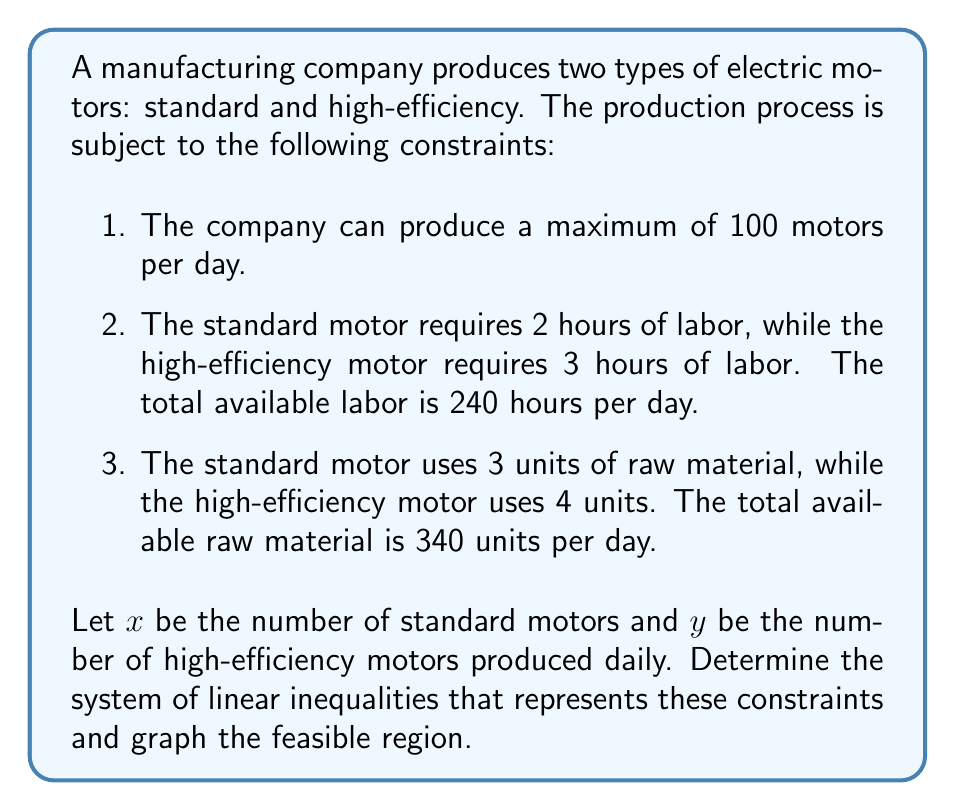Show me your answer to this math problem. Step 1: Formulate the system of linear inequalities

1. Total production constraint: $x + y \leq 100$
2. Labor constraint: $2x + 3y \leq 240$
3. Raw material constraint: $3x + 4y \leq 340$
4. Non-negativity constraints: $x \geq 0$, $y \geq 0$

Step 2: Graph the inequalities

To graph each inequality:
a) Convert the inequality to an equation
b) Plot the line
c) Shade the appropriate region

For $x + y \leq 100$:
- x-intercept: (100, 0)
- y-intercept: (0, 100)

For $2x + 3y \leq 240$:
- x-intercept: (120, 0)
- y-intercept: (0, 80)

For $3x + 4y \leq 340$:
- x-intercept: (113.33, 0)
- y-intercept: (0, 85)

Step 3: Identify the feasible region

The feasible region is the area where all inequalities are satisfied simultaneously. It is the intersection of the shaded regions for each inequality, bounded by the non-negativity constraints.

[asy]
import geometry;

size(200);

// Define axes
draw((-10,0)--(120,0),arrow=Arrow(TeXHead));
draw((0,-10)--(0,100),arrow=Arrow(TeXHead));

// Label axes
label("x", (120,0), E);
label("y", (0,100), N);

// Plot constraints
draw((100,0)--(0,100),blue);
draw((120,0)--(0,80),red);
draw((340/3,0)--(0,85),green);

// Shade feasible region
path region = (0,0)--(100,0)--(0,80)--cycle;
fill(region,paleblue+opacity(0.2));

// Label lines
label("x + y = 100", (50,50), NE, blue);
label("2x + 3y = 240", (60,40), SE, red);
label("3x + 4y = 340", (85,25), SE, green);

// Add points of interest
dot((0,0));
dot((100,0));
dot((0,80));
dot((60,40));
</asy]

Step 4: Identify the vertices of the feasible region

The vertices are the intersection points of the constraint lines:
- (0, 0): Origin
- (100, 0): x-axis intercept of $x + y = 100$
- (0, 80): y-axis intercept of $2x + 3y = 240$
- (60, 40): Intersection of $x + y = 100$ and $2x + 3y = 240$

These vertices define the boundaries of the feasible region.
Answer: System of inequalities: $x + y \leq 100$, $2x + 3y \leq 240$, $3x + 4y \leq 340$, $x \geq 0$, $y \geq 0$. Feasible region: Polygon with vertices (0,0), (100,0), (60,40), (0,80). 